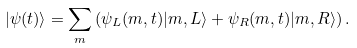<formula> <loc_0><loc_0><loc_500><loc_500>| \psi ( t ) \rangle = \sum _ { m } \left ( \psi _ { L } ( m , t ) | m , L \rangle + \psi _ { R } ( m , t ) | m , R \rangle \right ) .</formula> 